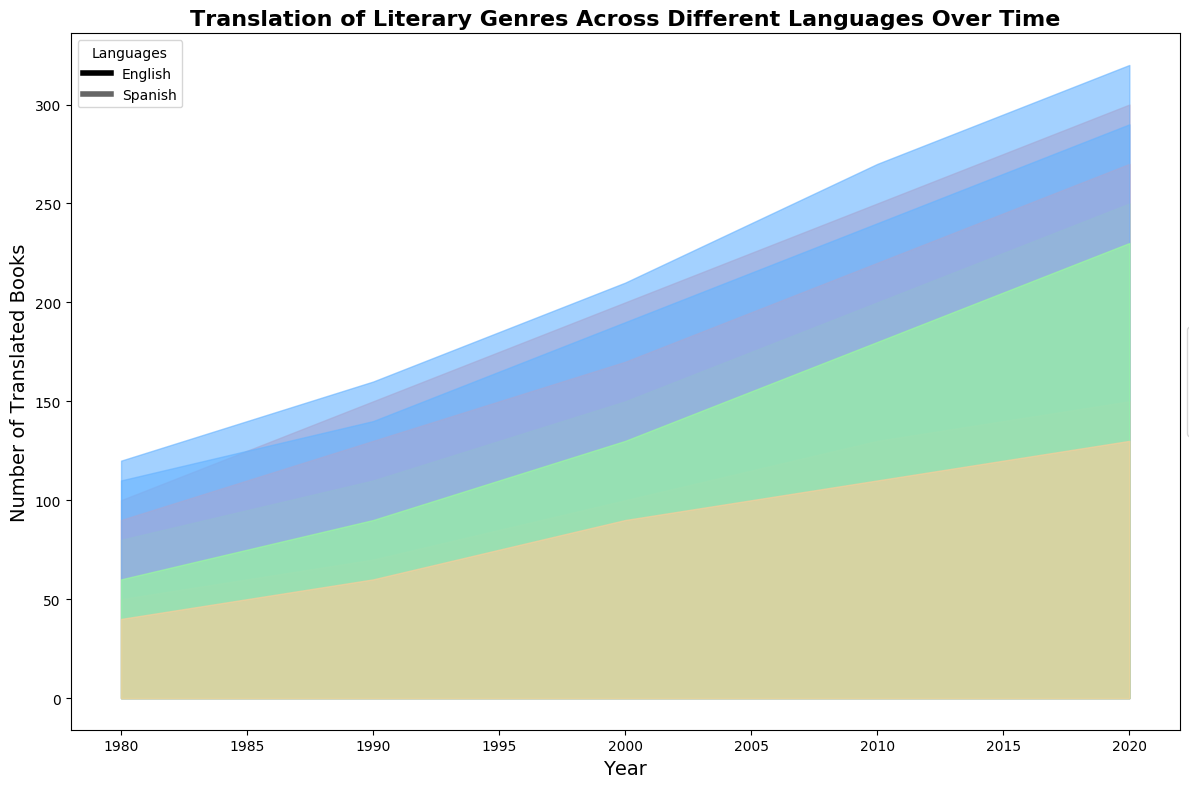Which language had more translated books in 2020, English or Spanish? Look at the sum of the areas for English and Spanish in 2020. English had contributions from all four genres, with the heights representing the number of books, while for Spanish, the corresponding values are slightly lower.
Answer: English Which literary genre saw the most significant increase in translated books between 1980 and 2020 for English? Check the differences in the heights of the areas between 1980 and 2020 for each genre. Science Fiction shows a considerable increase from 100 to 300 books.
Answer: Science Fiction By how many books did the number of Spanish Fantasy translation increase from 1980 to 2020? Calculate the difference in the height of the Spanish Fantasy area in 1980 and 2020. It increased from 60 to 230 books, so the difference is 230 - 60.
Answer: 170 How did the number of translated Romance books in English compare to Spanish in 1990? Compare the heights of the Romance sections for both languages in 1990. English had 160 translated Romance books, while Spanish had 140.
Answer: English had more What is the average number of Historical Fiction books translated per decade for Spanish between 1980 and 2020? Sum the numbers of Spanish Historical Fiction books across all decades (40+60+90+110+130) and divide by 5. The sum is 430, and the average is 430/5.
Answer: 86 Which genre had the least number of translated books in 2000 for English and how many? Observe that Historical Fiction had the smallest area in 2000 for English, representing 100 books.
Answer: Historical Fiction, 100 What was the total number of translated books for both languages in 2010? Sum the heights of all genres for both English and Spanish in 2010. English totals to 250+270+200+130=850, Spanish totals to 220+240+180+110=750. Combined total is 850+750.
Answer: 1600 Between 1990 and 2020, which genre had a higher increase in translated books for Spanish, Romance or Science Fiction? Calculate the difference for both genres between 1990 and 2020 for Spanish: Romance increased from 140 to 290 (150 books), Science Fiction from 130 to 270 (140 books).
Answer: Romance Which decade saw the highest overall number of translated books for English? Compare the total height of the areas for all genres in each decade for English. The 2020 areas (300+320+250+150 = 1020 books) are the tallest.
Answer: 2020 Which genre shows the least growth in translation numbers over the years for both languages? Compare the growth in the height of the areas for all genres across years; Historical Fiction shows the least growth overall.
Answer: Historical Fiction 